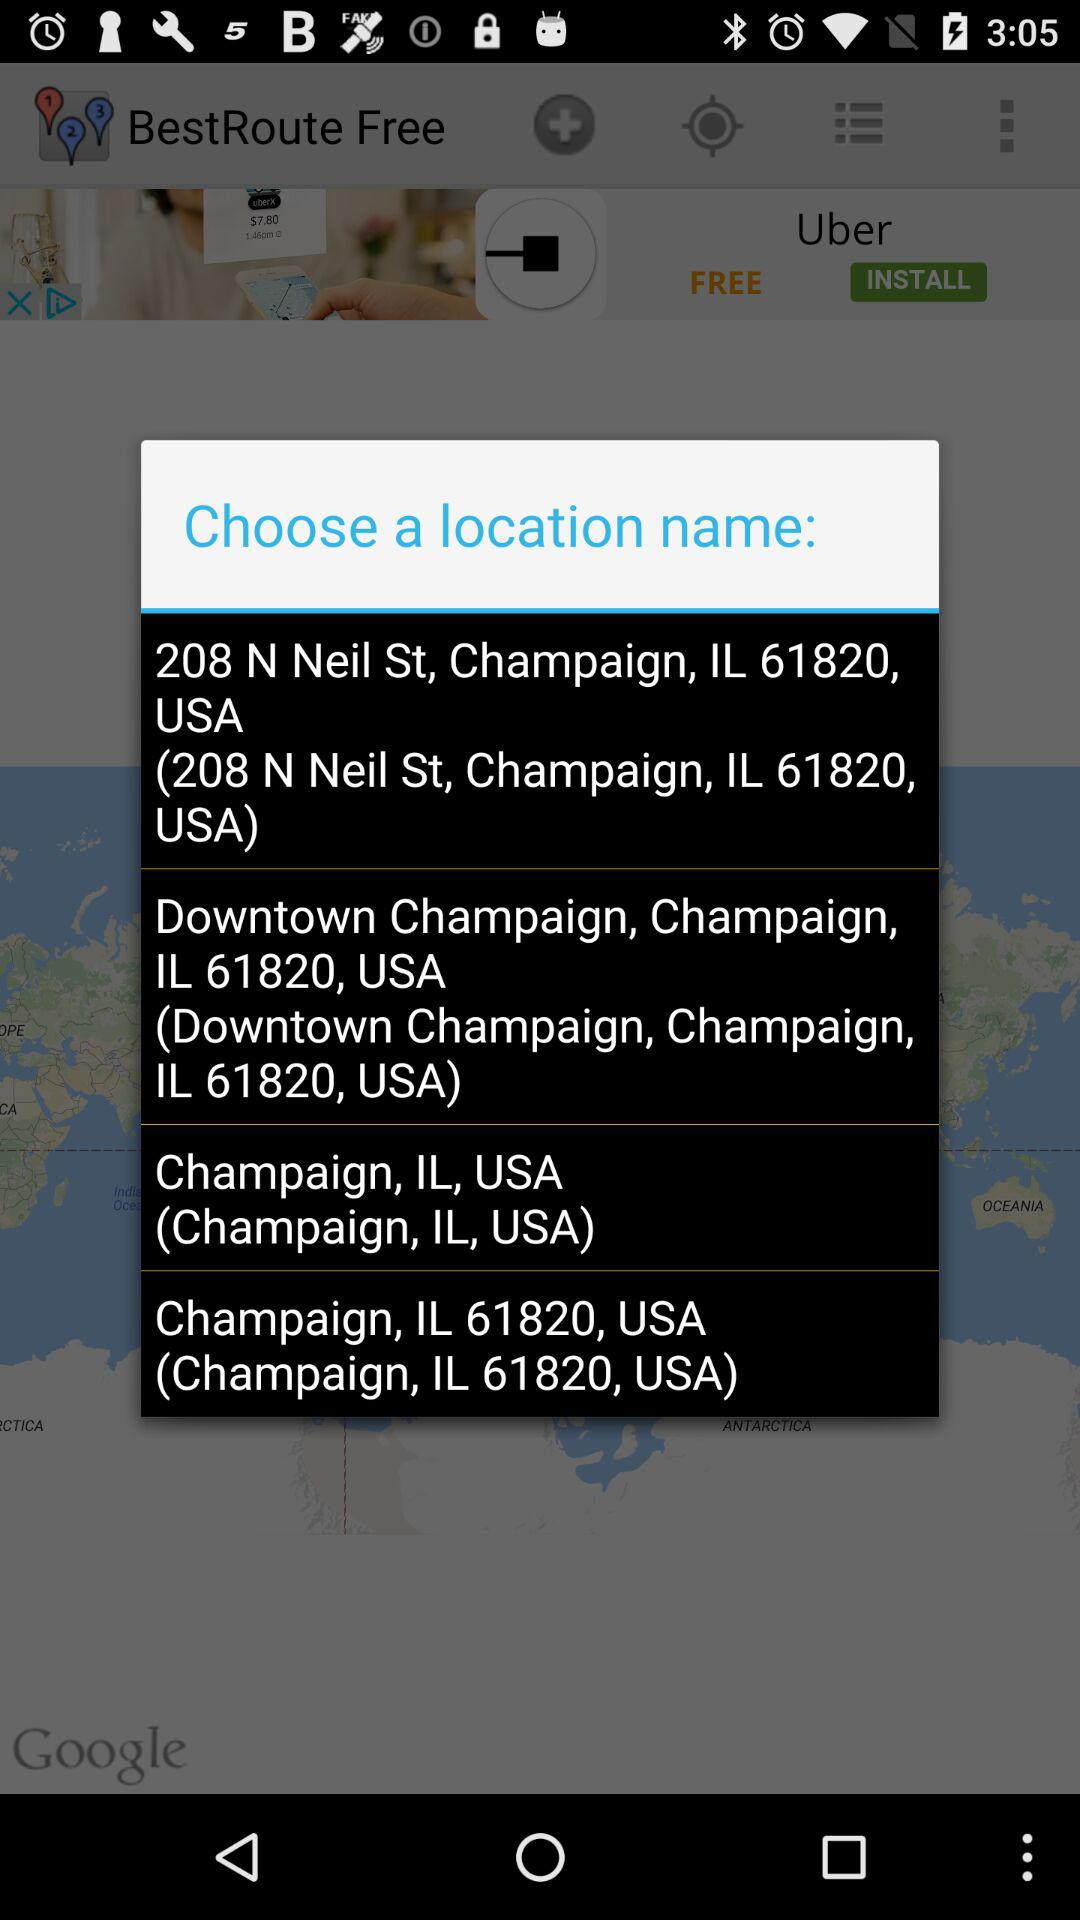What are the location options that I can select? The location options that I can select are "208 N Neil St, Champaign, IL 61820, USA (208 N Neil St, Champaign, IL 61820, USA)", "Downtown Champaign, Champaign, IL 61820, USA (Downtown Champaign, Champaign, IL 61820, USA)", "Champaign, IL, USA (Champaign, IL, USA)" and "Champaign, IL 61820, USA (Champaign, IL 61820, USA)". 